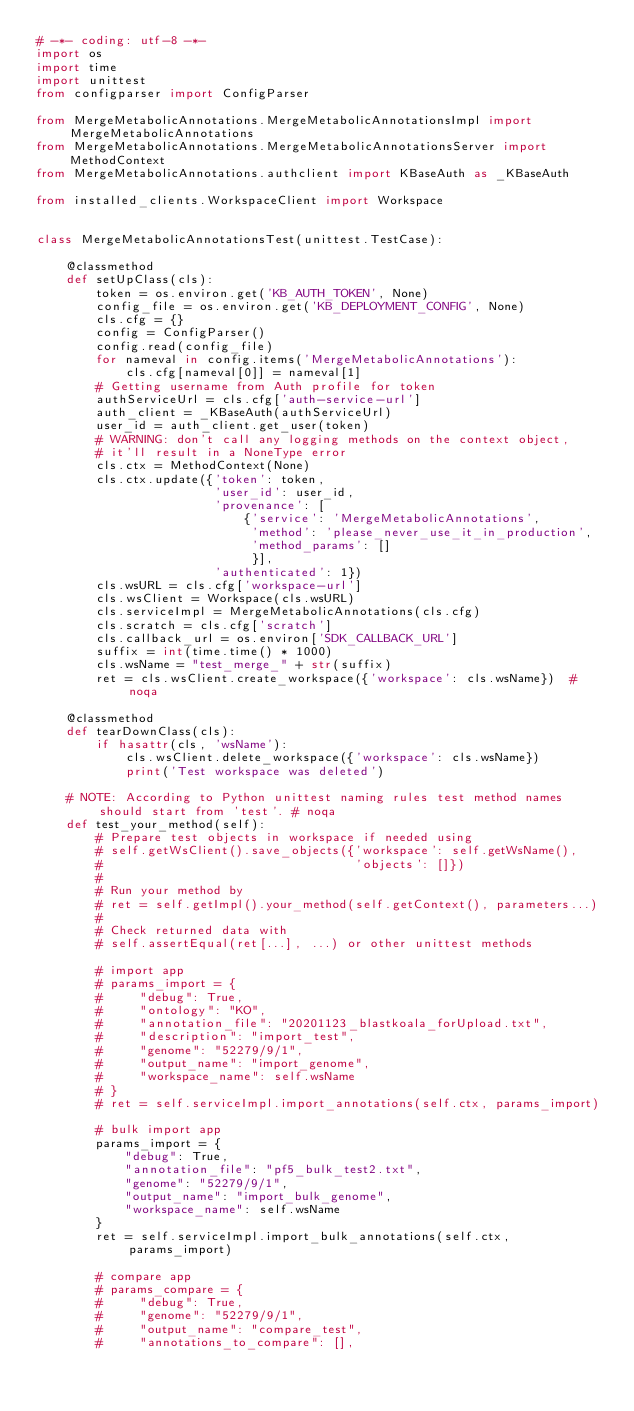<code> <loc_0><loc_0><loc_500><loc_500><_Python_># -*- coding: utf-8 -*-
import os
import time
import unittest
from configparser import ConfigParser

from MergeMetabolicAnnotations.MergeMetabolicAnnotationsImpl import MergeMetabolicAnnotations
from MergeMetabolicAnnotations.MergeMetabolicAnnotationsServer import MethodContext
from MergeMetabolicAnnotations.authclient import KBaseAuth as _KBaseAuth

from installed_clients.WorkspaceClient import Workspace


class MergeMetabolicAnnotationsTest(unittest.TestCase):

    @classmethod
    def setUpClass(cls):
        token = os.environ.get('KB_AUTH_TOKEN', None)
        config_file = os.environ.get('KB_DEPLOYMENT_CONFIG', None)
        cls.cfg = {}
        config = ConfigParser()
        config.read(config_file)
        for nameval in config.items('MergeMetabolicAnnotations'):
            cls.cfg[nameval[0]] = nameval[1]
        # Getting username from Auth profile for token
        authServiceUrl = cls.cfg['auth-service-url']
        auth_client = _KBaseAuth(authServiceUrl)
        user_id = auth_client.get_user(token)
        # WARNING: don't call any logging methods on the context object,
        # it'll result in a NoneType error
        cls.ctx = MethodContext(None)
        cls.ctx.update({'token': token,
                        'user_id': user_id,
                        'provenance': [
                            {'service': 'MergeMetabolicAnnotations',
                             'method': 'please_never_use_it_in_production',
                             'method_params': []
                             }],
                        'authenticated': 1})
        cls.wsURL = cls.cfg['workspace-url']
        cls.wsClient = Workspace(cls.wsURL)
        cls.serviceImpl = MergeMetabolicAnnotations(cls.cfg)
        cls.scratch = cls.cfg['scratch']
        cls.callback_url = os.environ['SDK_CALLBACK_URL']
        suffix = int(time.time() * 1000)
        cls.wsName = "test_merge_" + str(suffix)
        ret = cls.wsClient.create_workspace({'workspace': cls.wsName})  # noqa

    @classmethod
    def tearDownClass(cls):
        if hasattr(cls, 'wsName'):
            cls.wsClient.delete_workspace({'workspace': cls.wsName})
            print('Test workspace was deleted')

    # NOTE: According to Python unittest naming rules test method names should start from 'test'. # noqa
    def test_your_method(self):
        # Prepare test objects in workspace if needed using
        # self.getWsClient().save_objects({'workspace': self.getWsName(),
        #                                  'objects': []})
        #
        # Run your method by
        # ret = self.getImpl().your_method(self.getContext(), parameters...)
        #
        # Check returned data with
        # self.assertEqual(ret[...], ...) or other unittest methods

        # import app
        # params_import = {
        #     "debug": True,
        #     "ontology": "KO",
        #     "annotation_file": "20201123_blastkoala_forUpload.txt",
        #     "description": "import_test",
        #     "genome": "52279/9/1",
        #     "output_name": "import_genome",
        #     "workspace_name": self.wsName
        # }
        # ret = self.serviceImpl.import_annotations(self.ctx, params_import)

        # bulk import app
        params_import = {
            "debug": True,
            "annotation_file": "pf5_bulk_test2.txt",
            "genome": "52279/9/1",
            "output_name": "import_bulk_genome",
            "workspace_name": self.wsName
        }
        ret = self.serviceImpl.import_bulk_annotations(self.ctx, params_import)

        # compare app
        # params_compare = {
        #     "debug": True,
        #     "genome": "52279/9/1",
        #     "output_name": "compare_test",
        #     "annotations_to_compare": [],</code> 